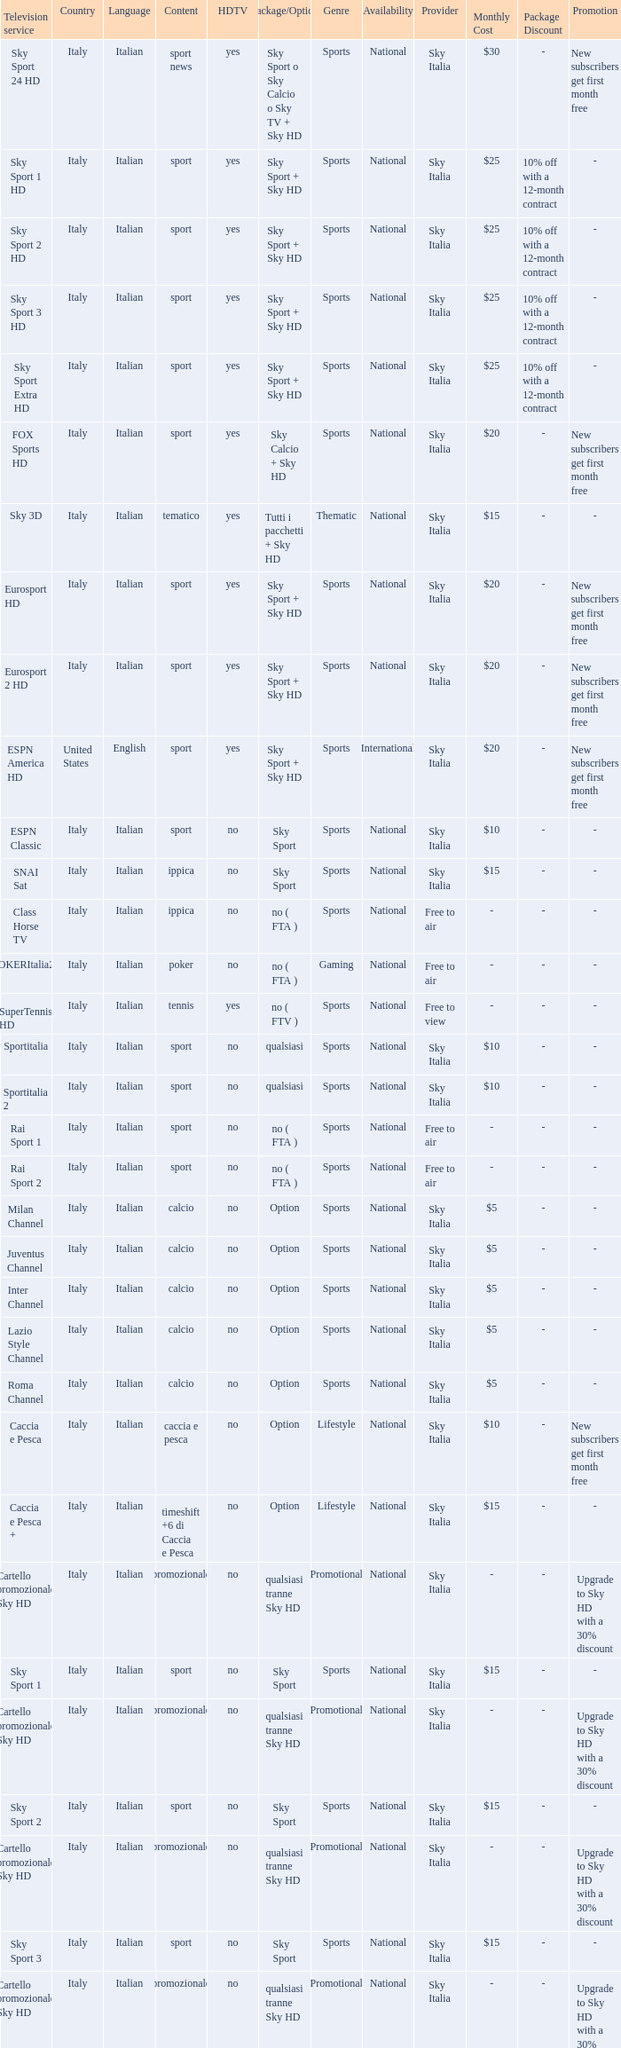What is Country, when Television Service is Eurosport 2? Italy. 